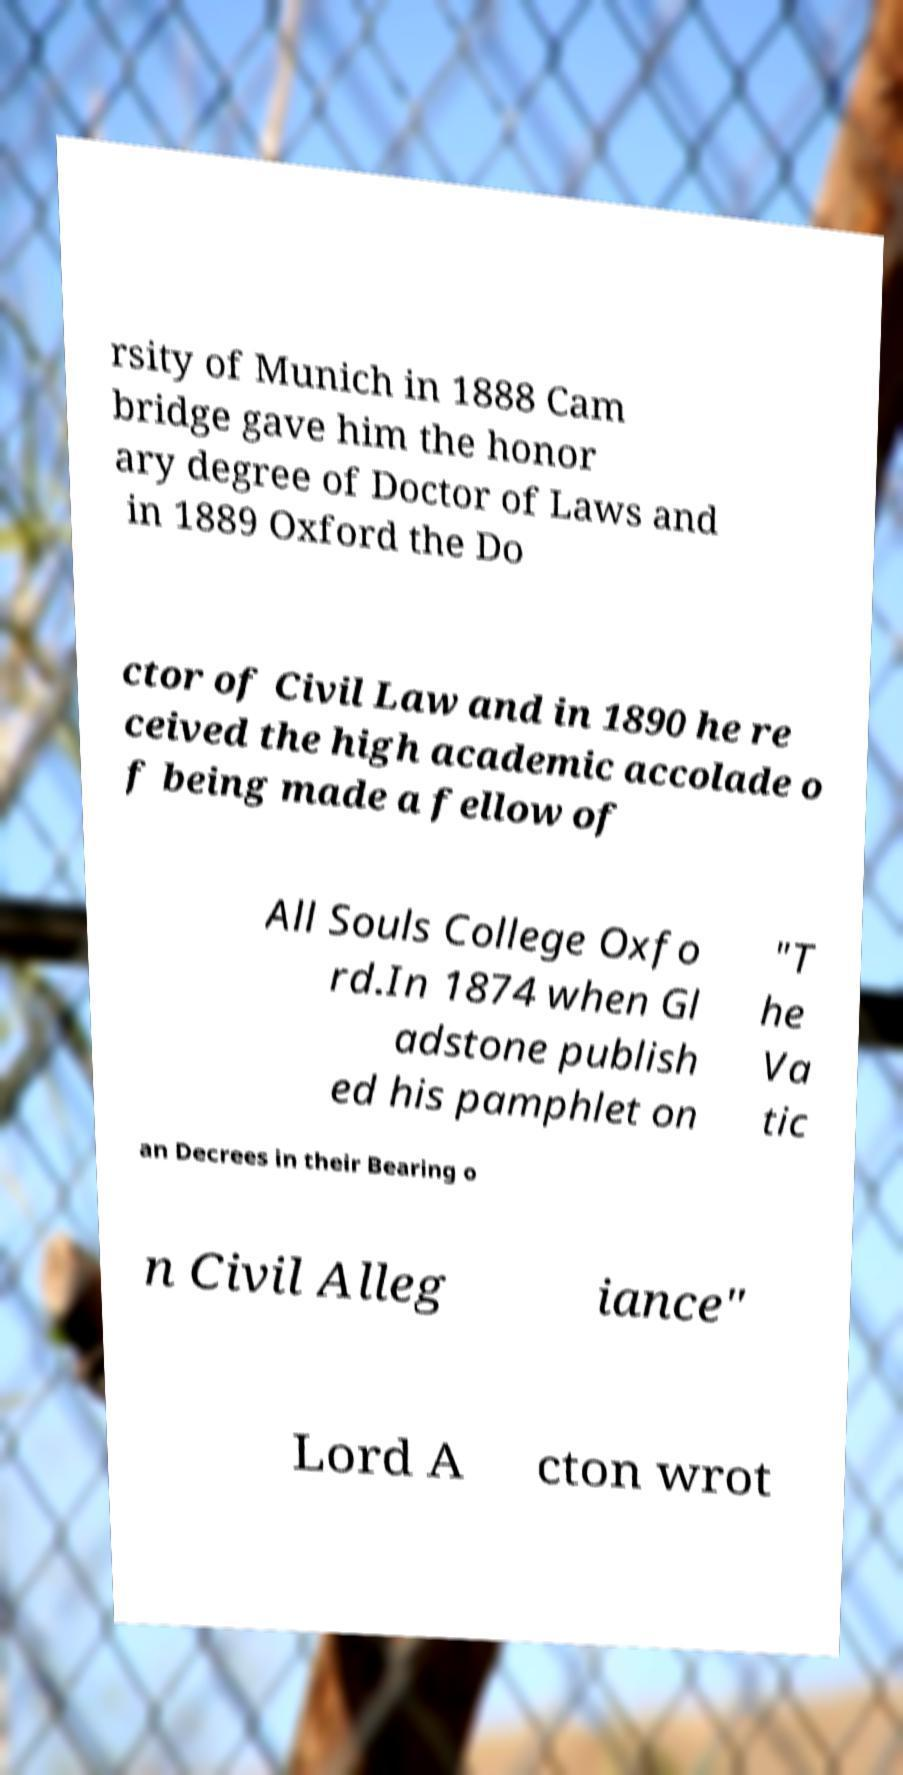Can you read and provide the text displayed in the image?This photo seems to have some interesting text. Can you extract and type it out for me? rsity of Munich in 1888 Cam bridge gave him the honor ary degree of Doctor of Laws and in 1889 Oxford the Do ctor of Civil Law and in 1890 he re ceived the high academic accolade o f being made a fellow of All Souls College Oxfo rd.In 1874 when Gl adstone publish ed his pamphlet on "T he Va tic an Decrees in their Bearing o n Civil Alleg iance" Lord A cton wrot 